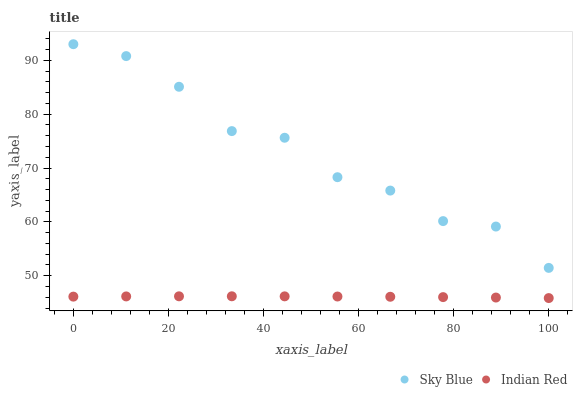Does Indian Red have the minimum area under the curve?
Answer yes or no. Yes. Does Sky Blue have the maximum area under the curve?
Answer yes or no. Yes. Does Indian Red have the maximum area under the curve?
Answer yes or no. No. Is Indian Red the smoothest?
Answer yes or no. Yes. Is Sky Blue the roughest?
Answer yes or no. Yes. Is Indian Red the roughest?
Answer yes or no. No. Does Indian Red have the lowest value?
Answer yes or no. Yes. Does Sky Blue have the highest value?
Answer yes or no. Yes. Does Indian Red have the highest value?
Answer yes or no. No. Is Indian Red less than Sky Blue?
Answer yes or no. Yes. Is Sky Blue greater than Indian Red?
Answer yes or no. Yes. Does Indian Red intersect Sky Blue?
Answer yes or no. No. 